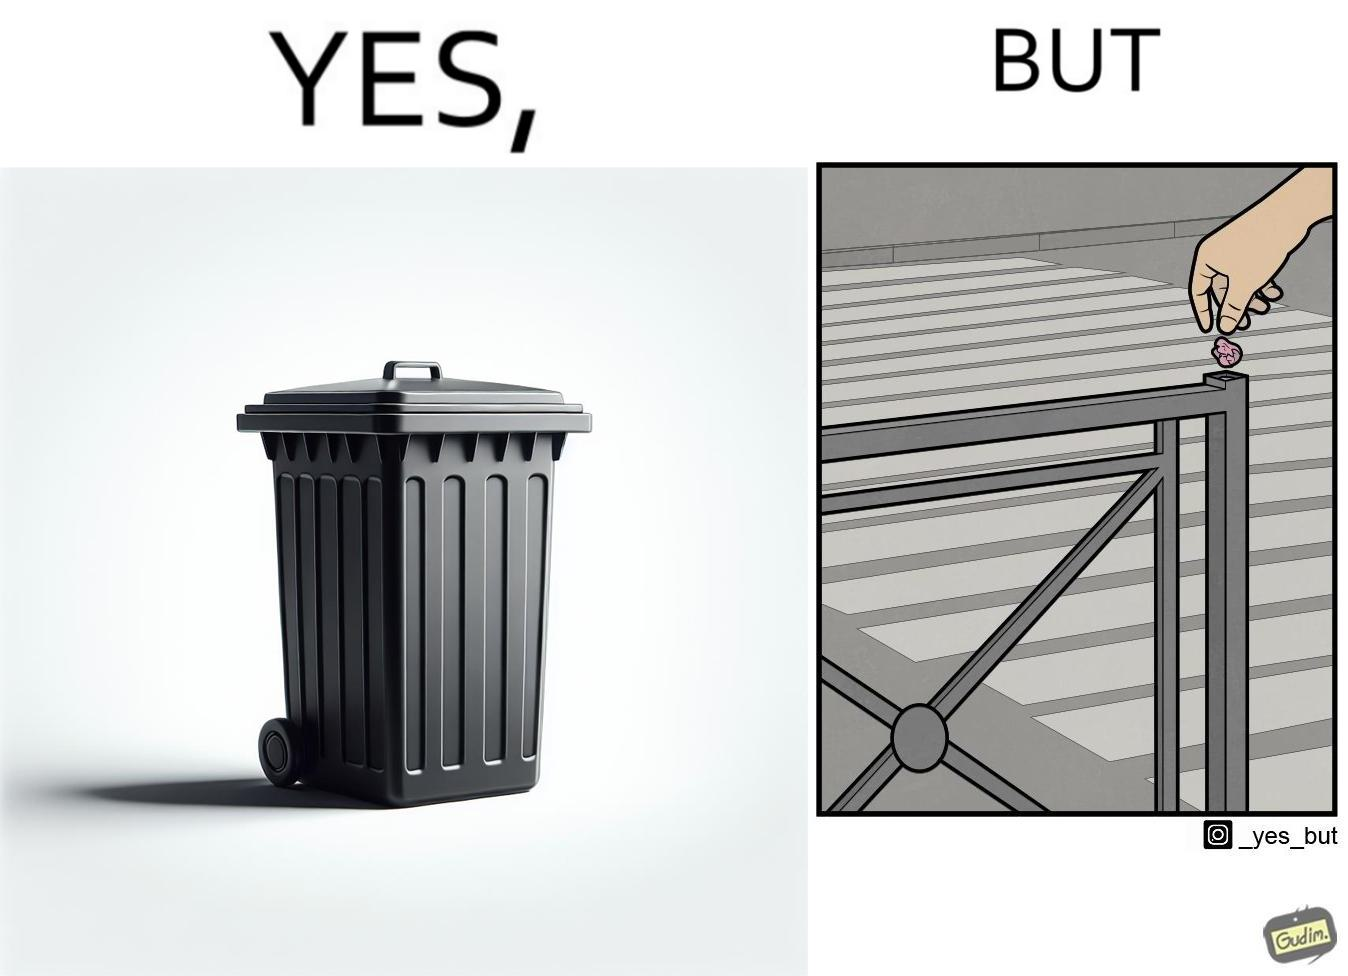What is shown in this image? The images are ironic because even though garbage bins are provided for humans to dispose waste, by habit humans still choose to make surroundings dirty by disposing garbage improperly 